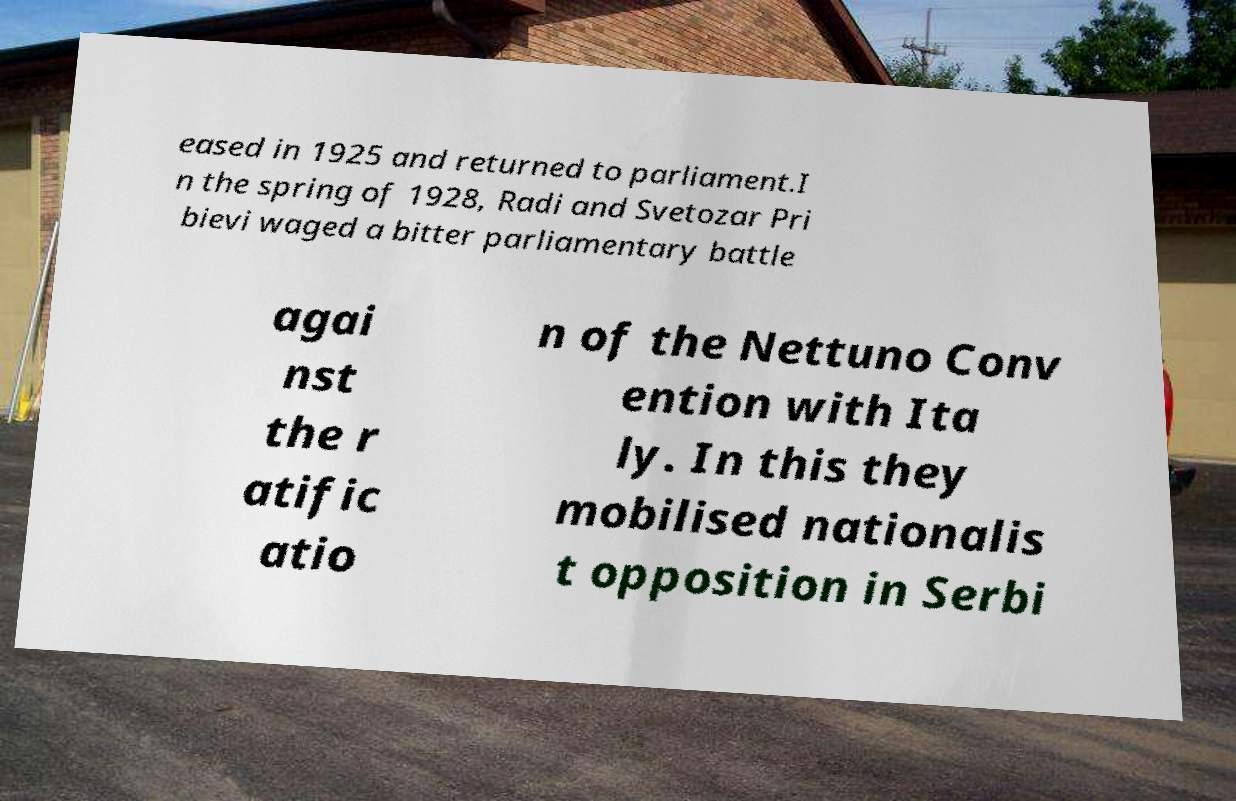Could you extract and type out the text from this image? eased in 1925 and returned to parliament.I n the spring of 1928, Radi and Svetozar Pri bievi waged a bitter parliamentary battle agai nst the r atific atio n of the Nettuno Conv ention with Ita ly. In this they mobilised nationalis t opposition in Serbi 